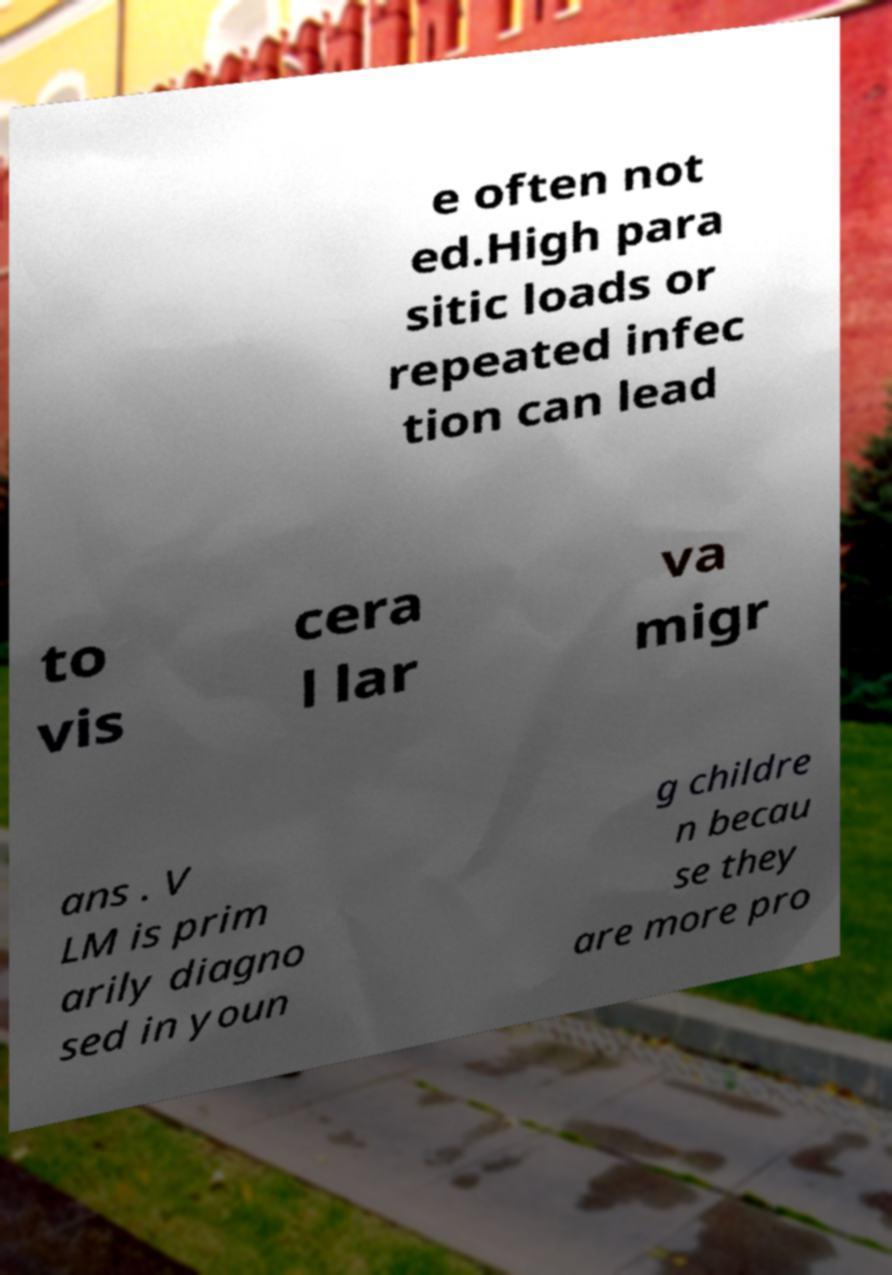Please identify and transcribe the text found in this image. e often not ed.High para sitic loads or repeated infec tion can lead to vis cera l lar va migr ans . V LM is prim arily diagno sed in youn g childre n becau se they are more pro 